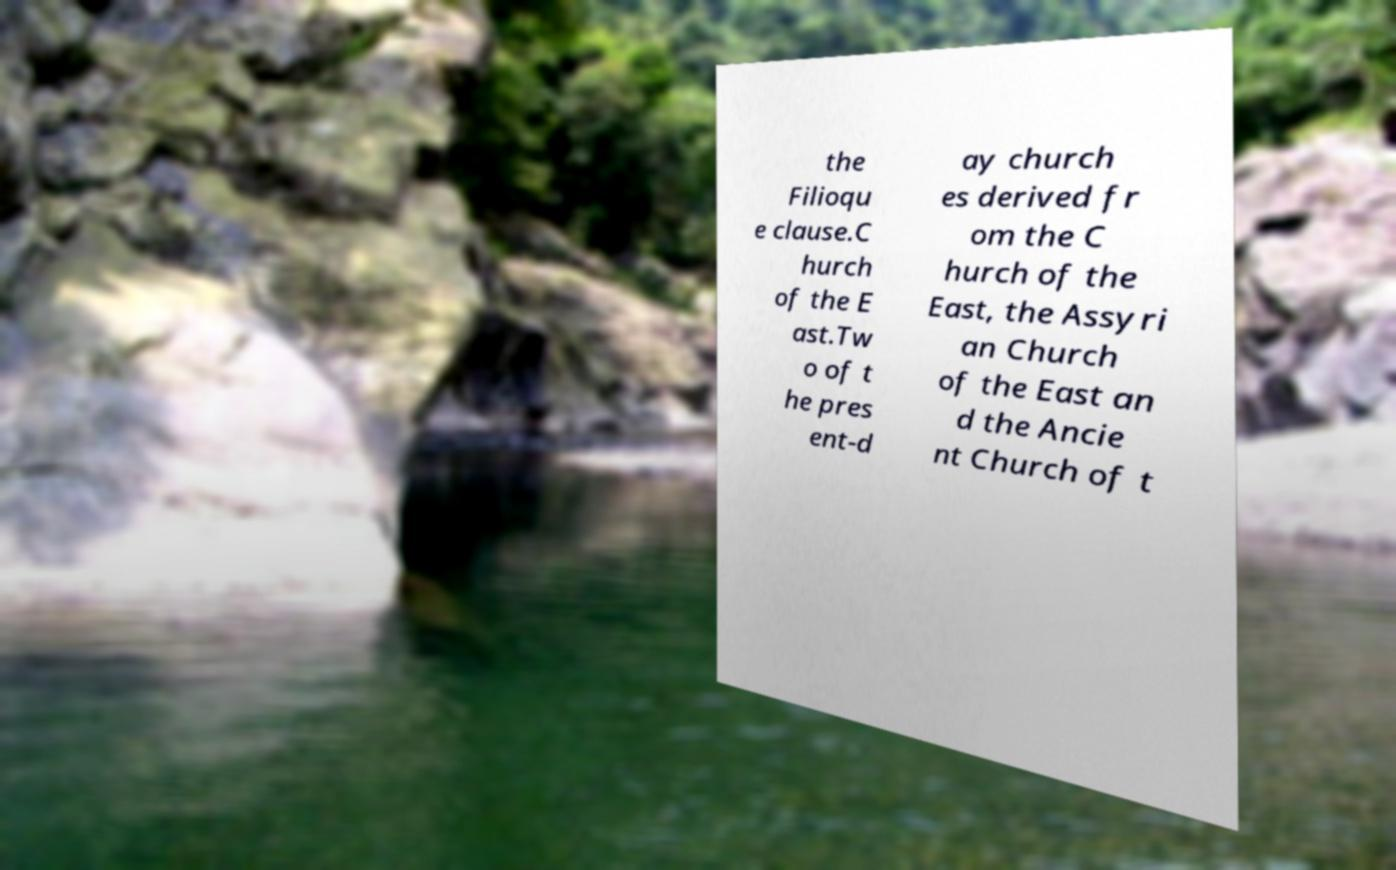Could you extract and type out the text from this image? the Filioqu e clause.C hurch of the E ast.Tw o of t he pres ent-d ay church es derived fr om the C hurch of the East, the Assyri an Church of the East an d the Ancie nt Church of t 